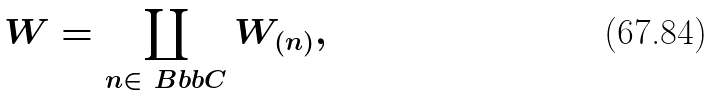Convert formula to latex. <formula><loc_0><loc_0><loc_500><loc_500>W = \coprod _ { n \in \ B b b { C } } W _ { ( n ) } ,</formula> 